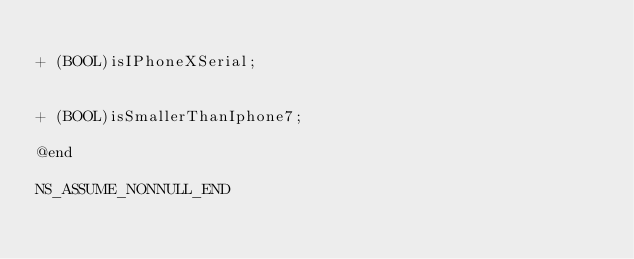Convert code to text. <code><loc_0><loc_0><loc_500><loc_500><_C_>
+ (BOOL)isIPhoneXSerial;


+ (BOOL)isSmallerThanIphone7;

@end

NS_ASSUME_NONNULL_END
</code> 